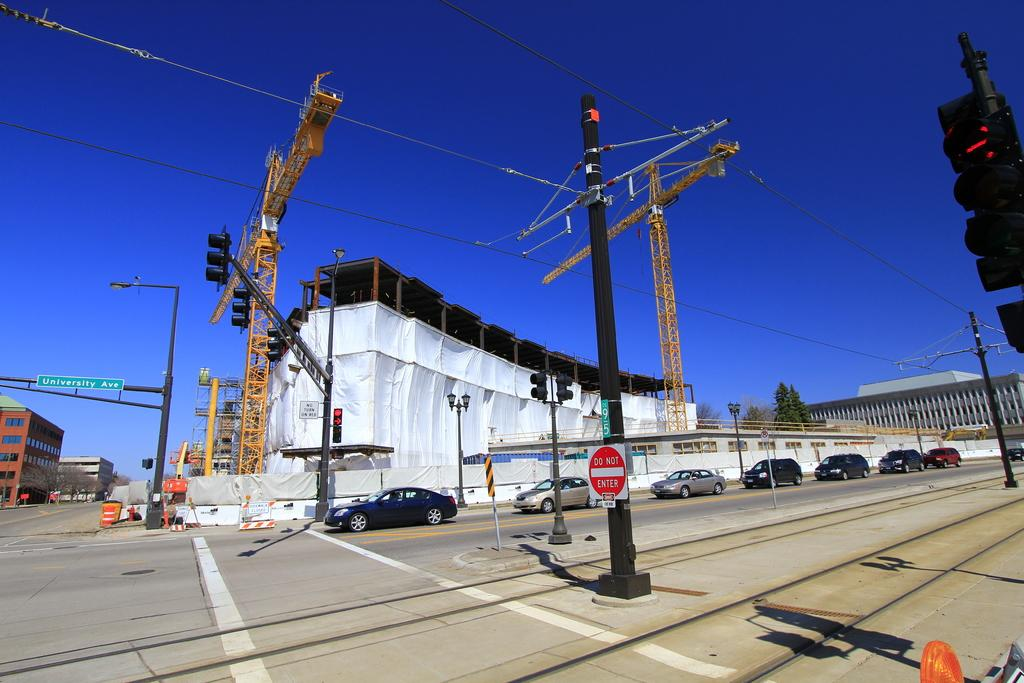<image>
Give a short and clear explanation of the subsequent image. a do not enter sign next to a street 